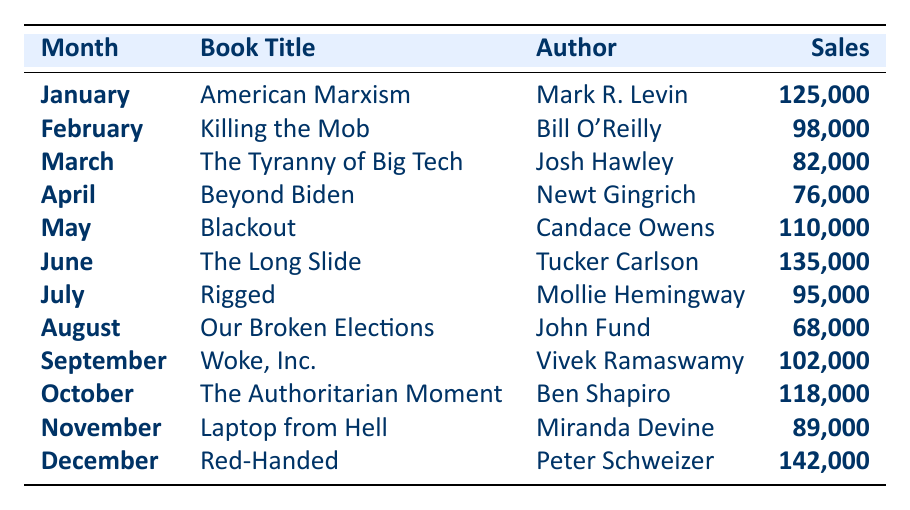What was the best-selling book in December? The table shows that the book with the highest sales in December is "Red-Handed" by Peter Schweizer, with sales of 142,000 copies.
Answer: Red-Handed Which book sold the least in August? According to the table, "Our Broken Elections" by John Fund had the lowest sales in August, totaling 68,000 copies.
Answer: Our Broken Elections What is the total sales for the six months from January to June? The sales figures from January to June are 125,000 (Jan) + 98,000 (Feb) + 82,000 (Mar) + 76,000 (Apr) + 110,000 (May) + 135,000 (Jun) = 626,000.
Answer: 626,000 Did any book sell more than 100,000 copies in October? The table shows that "The Authoritarian Moment" by Ben Shapiro sold 118,000 copies in October, which is indeed more than 100,000.
Answer: Yes What is the difference in sales between the top-selling book of the year and the lowest-selling book? The top-selling book was "Red-Handed" with 142,000 copies, and the lowest was "Our Broken Elections" with 68,000 copies. The difference is 142,000 - 68,000 = 74,000.
Answer: 74,000 Which month had two books selling over 100,000 copies? In June and December, the books "The Long Slide" (135,000) and "Red-Handed" (142,000) sold over 100,000 copies.
Answer: June and December If we consider the median sales across these months, what is it? The sales sorted from lowest to highest are: 68,000, 76,000, 82,000, 89,000, 95,000, 98,000, 102,000, 110,000, 118,000, 125,000, 135,000, 142,000. There are 12 data points, so the median is the average of the 6th and 7th values: (98,000 + 102,000) / 2 = 100,000.
Answer: 100,000 What was the sales figure for May, and how does it compare to November's sales? May had sales of 110,000 while November had 89,000. Comparing the two, May had 21,000 more sales than November.
Answer: 21,000 more Which author had the highest sales in a single month? The highest sales in a single month was by Peter Schweizer with "Red-Handed" selling 142,000 copies in December.
Answer: Peter Schweizer Which book was released in July, and how many copies did it sell? In July, "Rigged" by Mollie Hemingway was released, and it sold 95,000 copies.
Answer: Rigged, 95,000 copies 